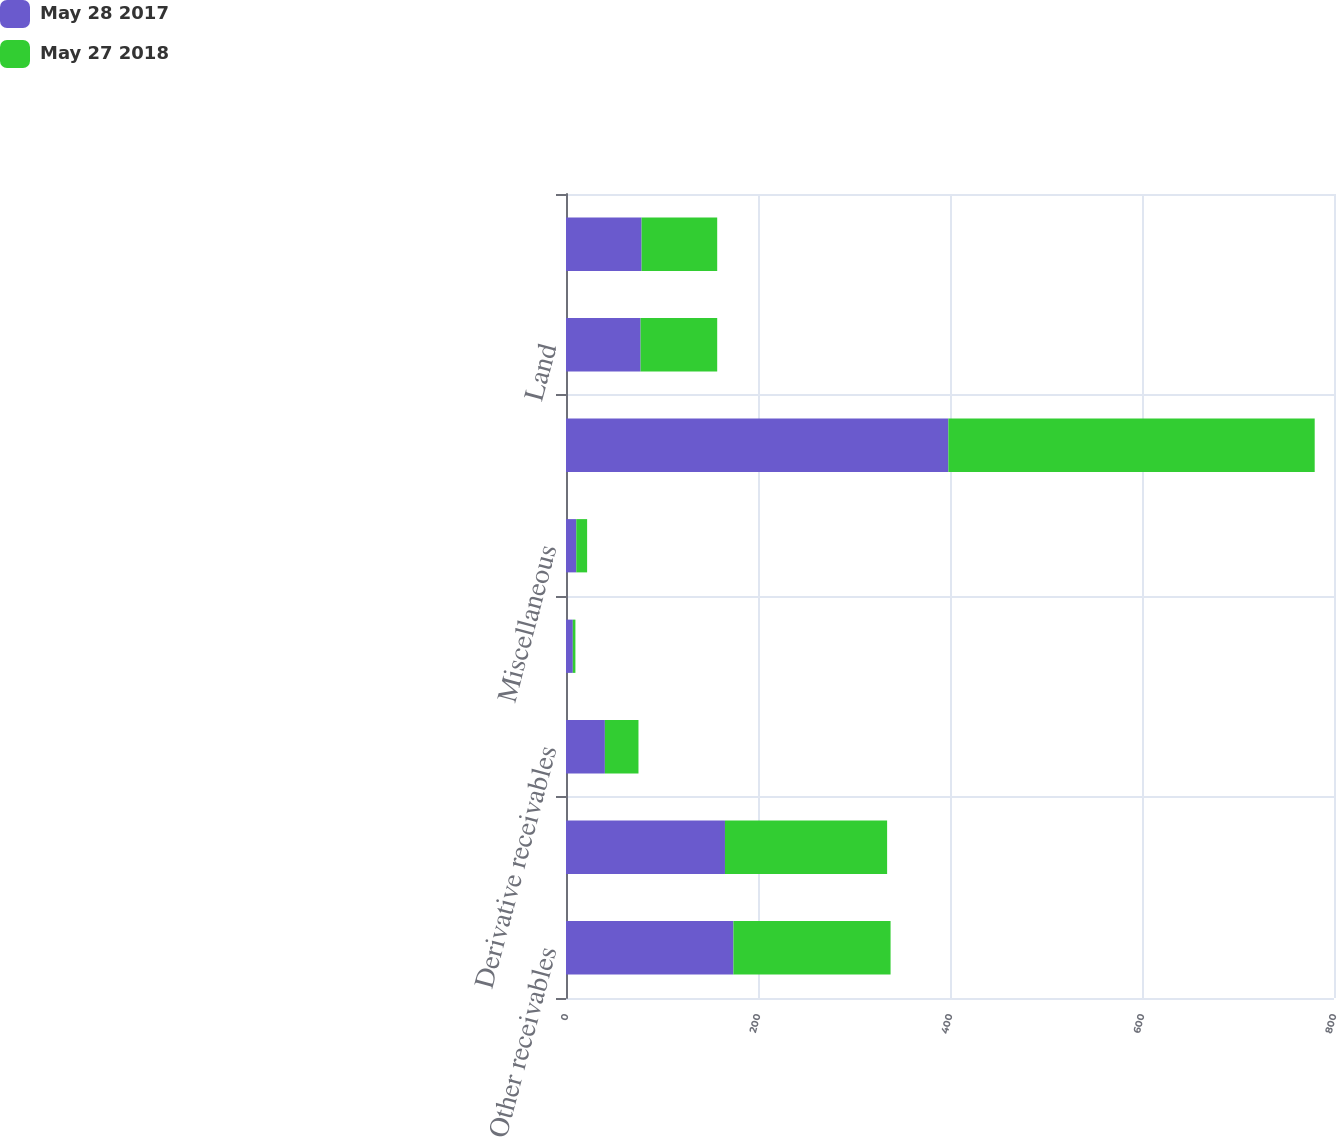Convert chart to OTSL. <chart><loc_0><loc_0><loc_500><loc_500><stacked_bar_chart><ecel><fcel>Other receivables<fcel>Prepaid expenses<fcel>Derivative receivables<fcel>Grain contracts<fcel>Miscellaneous<fcel>Total<fcel>Land<fcel>Buildings<nl><fcel>May 28 2017<fcel>174.4<fcel>165.6<fcel>40.5<fcel>7.1<fcel>10.7<fcel>398.3<fcel>77.7<fcel>78.75<nl><fcel>May 27 2018<fcel>163.7<fcel>168.9<fcel>35<fcel>2.7<fcel>11.3<fcel>381.6<fcel>79.8<fcel>78.75<nl></chart> 